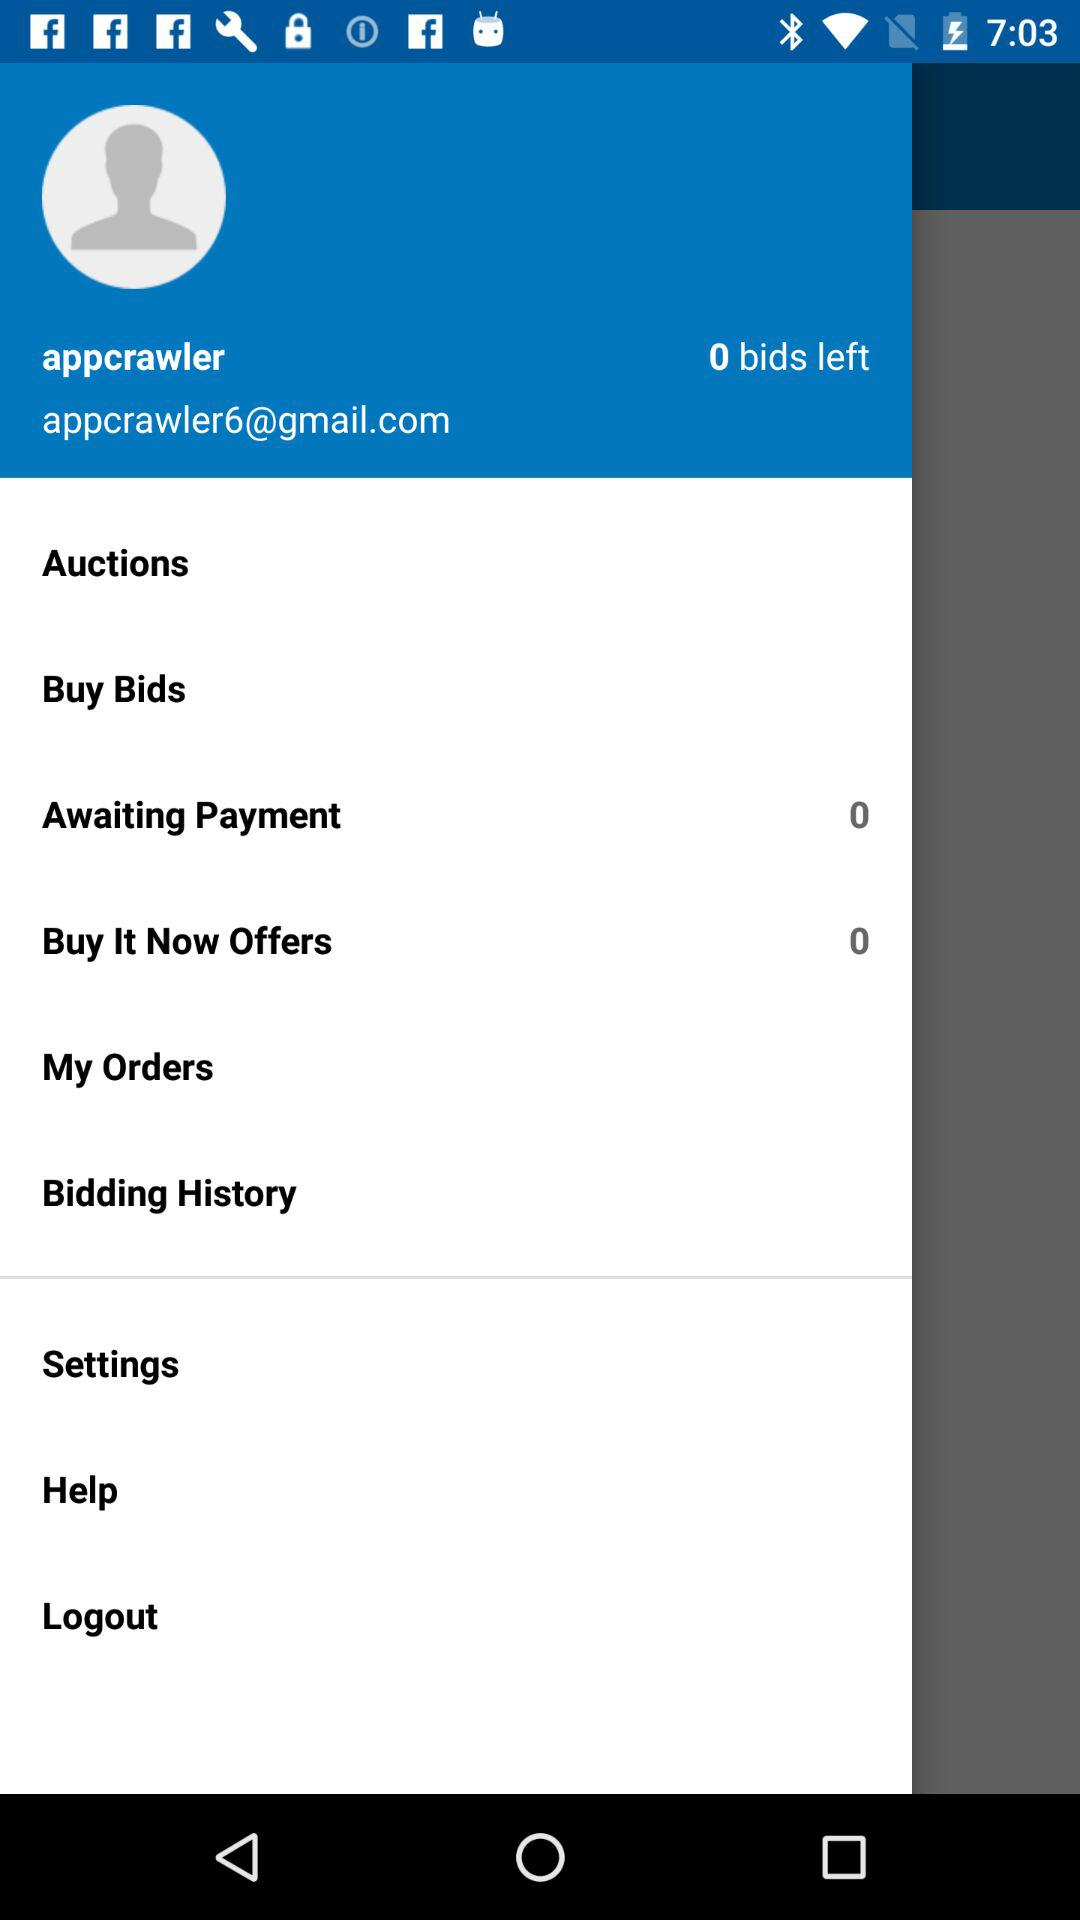How much is awaiting payment? The awaiting payment is 0. 